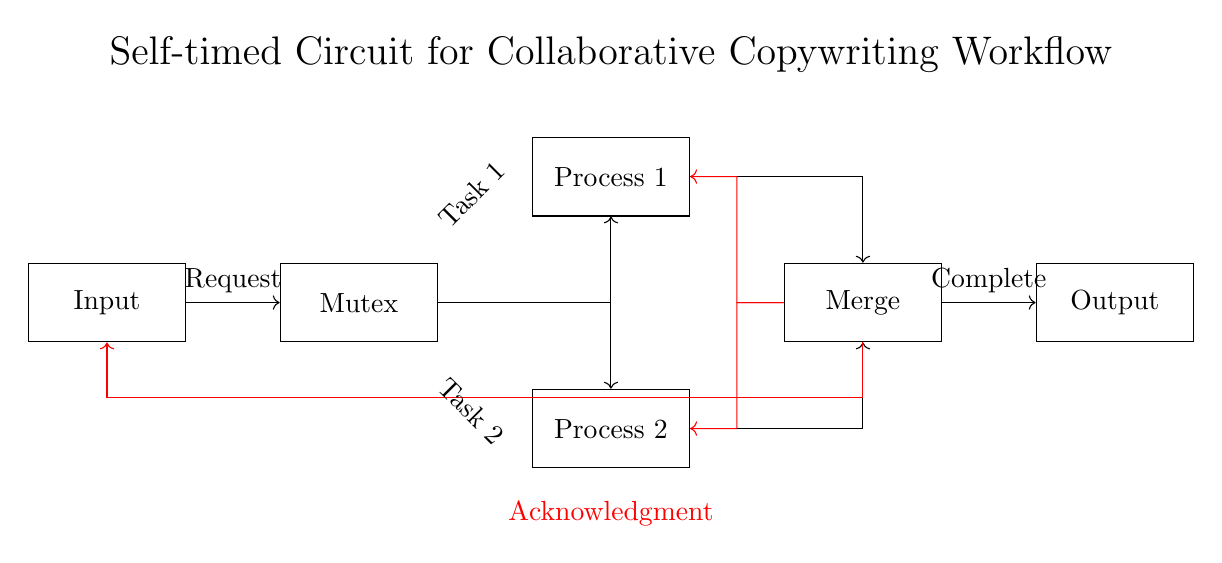What is the first component in the circuit? The first component is labeled as "Input," which is the starting node of the circuit. It receives requests for processing.
Answer: Input What connects the "Input" and "Mutex" components? The connection is indicated by an arrow pointing from "Input" to "Mutex," representing a directional flow of signals.
Answer: An arrow How many processes are there in the diagram? There are two processes, which are labeled "Process 1" and "Process 2," and they are positioned on either side of the "Merge" component.
Answer: Two What type of circuit is illustrated in this diagram? The circuit is described as a "Self-timed circuit," emphasizing its asynchronous nature designed for collaboration in workflows.
Answer: Self-timed What is indicated by the red acknowledgment signals? The red acknowledgment signals show that information is being sent back from the "Merge" component to the "Input," "Process 1," and "Process 2," confirming the completion of tasks.
Answer: Completion confirmation What do the two tasks do in the context of the circuit? The tasks represent individual operations that can process input data independently before merging the results. They are marked as "Task 1" and "Task 2."
Answer: Independent operations 